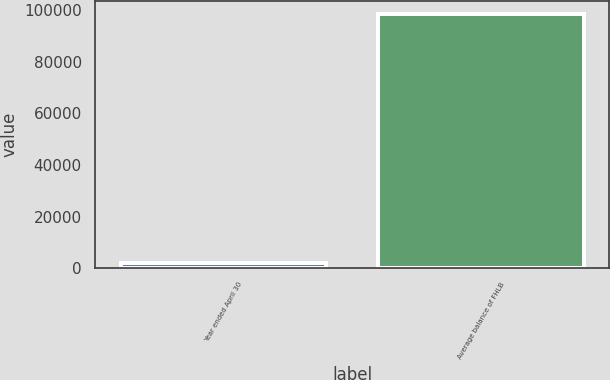Convert chart to OTSL. <chart><loc_0><loc_0><loc_500><loc_500><bar_chart><fcel>Year ended April 30<fcel>Average balance of FHLB<nl><fcel>2010<fcel>98767<nl></chart> 